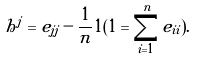Convert formula to latex. <formula><loc_0><loc_0><loc_500><loc_500>h ^ { j } = e _ { j j } - \frac { 1 } { n } 1 ( 1 = \sum _ { i = 1 } ^ { n } e _ { i i } ) .</formula> 